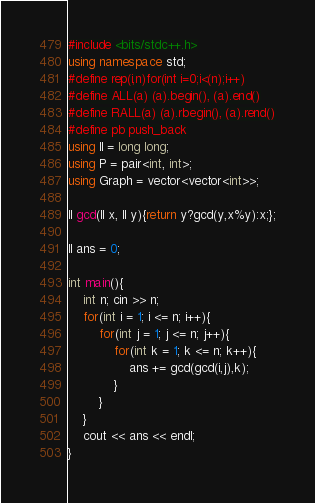Convert code to text. <code><loc_0><loc_0><loc_500><loc_500><_C++_>#include <bits/stdc++.h>
using namespace std;
#define rep(i,n)for(int i=0;i<(n);i++)
#define ALL(a) (a).begin(), (a).end()
#define RALL(a) (a).rbegin(), (a).rend()
#define pb push_back
using ll = long long;
using P = pair<int, int>;
using Graph = vector<vector<int>>;

ll gcd(ll x, ll y){return y?gcd(y,x%y):x;};

ll ans = 0;

int main(){
    int n; cin >> n;
    for(int i = 1; i <= n; i++){
        for(int j = 1; j <= n; j++){
            for(int k = 1; k <= n; k++){
                ans += gcd(gcd(i,j),k);
            }
        }
    }
    cout << ans << endl;
}</code> 